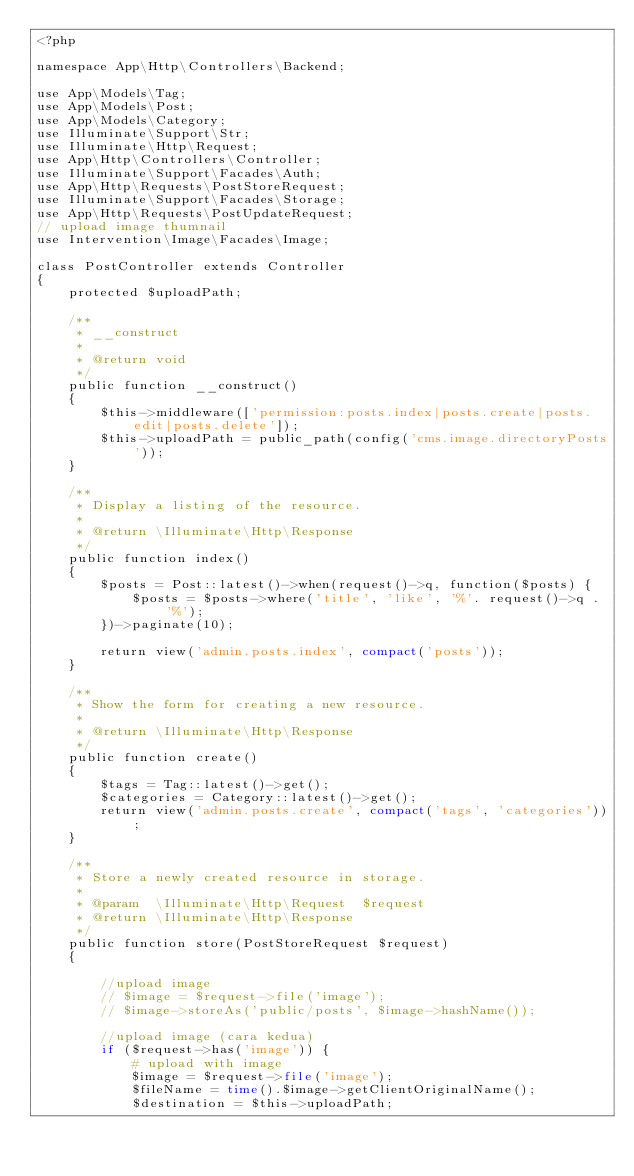<code> <loc_0><loc_0><loc_500><loc_500><_PHP_><?php

namespace App\Http\Controllers\Backend;

use App\Models\Tag;
use App\Models\Post;
use App\Models\Category;
use Illuminate\Support\Str;
use Illuminate\Http\Request;
use App\Http\Controllers\Controller;
use Illuminate\Support\Facades\Auth;
use App\Http\Requests\PostStoreRequest;
use Illuminate\Support\Facades\Storage;
use App\Http\Requests\PostUpdateRequest;
// upload image thumnail
use Intervention\Image\Facades\Image;

class PostController extends Controller
{
    protected $uploadPath;

    /**
     * __construct
     *
     * @return void
     */
    public function __construct()
    {
        $this->middleware(['permission:posts.index|posts.create|posts.edit|posts.delete']);
        $this->uploadPath = public_path(config('cms.image.directoryPosts'));
    }

    /**
     * Display a listing of the resource.
     *
     * @return \Illuminate\Http\Response
     */
    public function index()
    {
        $posts = Post::latest()->when(request()->q, function($posts) {
            $posts = $posts->where('title', 'like', '%'. request()->q . '%');
        })->paginate(10);

        return view('admin.posts.index', compact('posts'));
    }

    /**
     * Show the form for creating a new resource.
     *
     * @return \Illuminate\Http\Response
     */
    public function create()
    {
        $tags = Tag::latest()->get();
        $categories = Category::latest()->get();
        return view('admin.posts.create', compact('tags', 'categories'));
    }

    /**
     * Store a newly created resource in storage.
     *
     * @param  \Illuminate\Http\Request  $request
     * @return \Illuminate\Http\Response
     */
    public function store(PostStoreRequest $request)
    {

        //upload image
        // $image = $request->file('image');
        // $image->storeAs('public/posts', $image->hashName());

        //upload image (cara kedua)
        if ($request->has('image')) {
            # upload with image
            $image = $request->file('image');
            $fileName = time().$image->getClientOriginalName();
            $destination = $this->uploadPath;
            </code> 